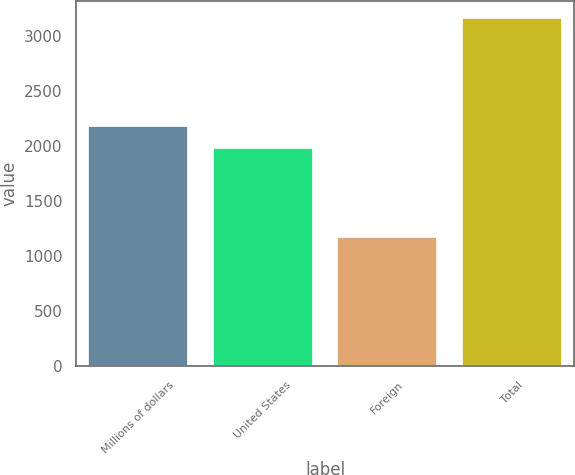<chart> <loc_0><loc_0><loc_500><loc_500><bar_chart><fcel>Millions of dollars<fcel>United States<fcel>Foreign<fcel>Total<nl><fcel>2186.8<fcel>1988<fcel>1175<fcel>3163<nl></chart> 